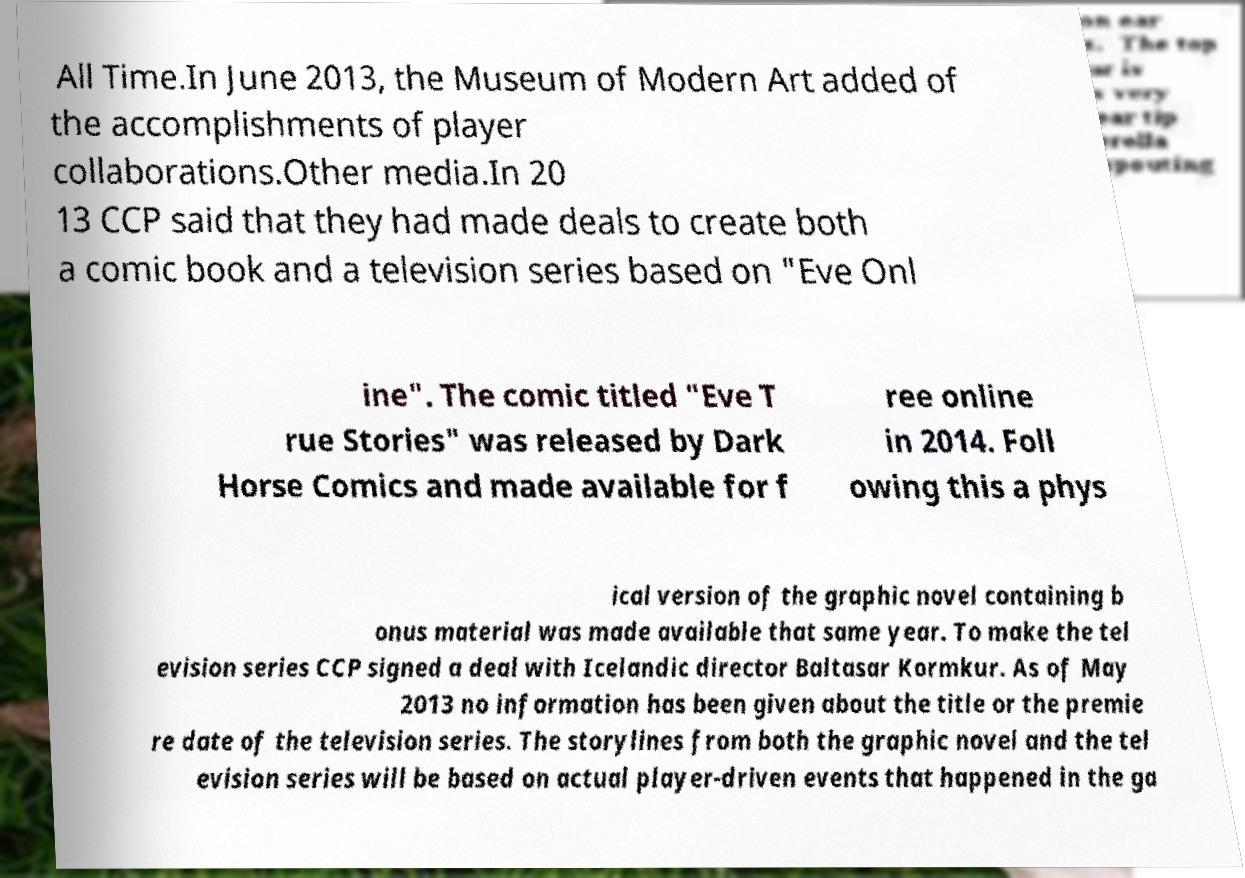Could you assist in decoding the text presented in this image and type it out clearly? All Time.In June 2013, the Museum of Modern Art added of the accomplishments of player collaborations.Other media.In 20 13 CCP said that they had made deals to create both a comic book and a television series based on "Eve Onl ine". The comic titled "Eve T rue Stories" was released by Dark Horse Comics and made available for f ree online in 2014. Foll owing this a phys ical version of the graphic novel containing b onus material was made available that same year. To make the tel evision series CCP signed a deal with Icelandic director Baltasar Kormkur. As of May 2013 no information has been given about the title or the premie re date of the television series. The storylines from both the graphic novel and the tel evision series will be based on actual player-driven events that happened in the ga 